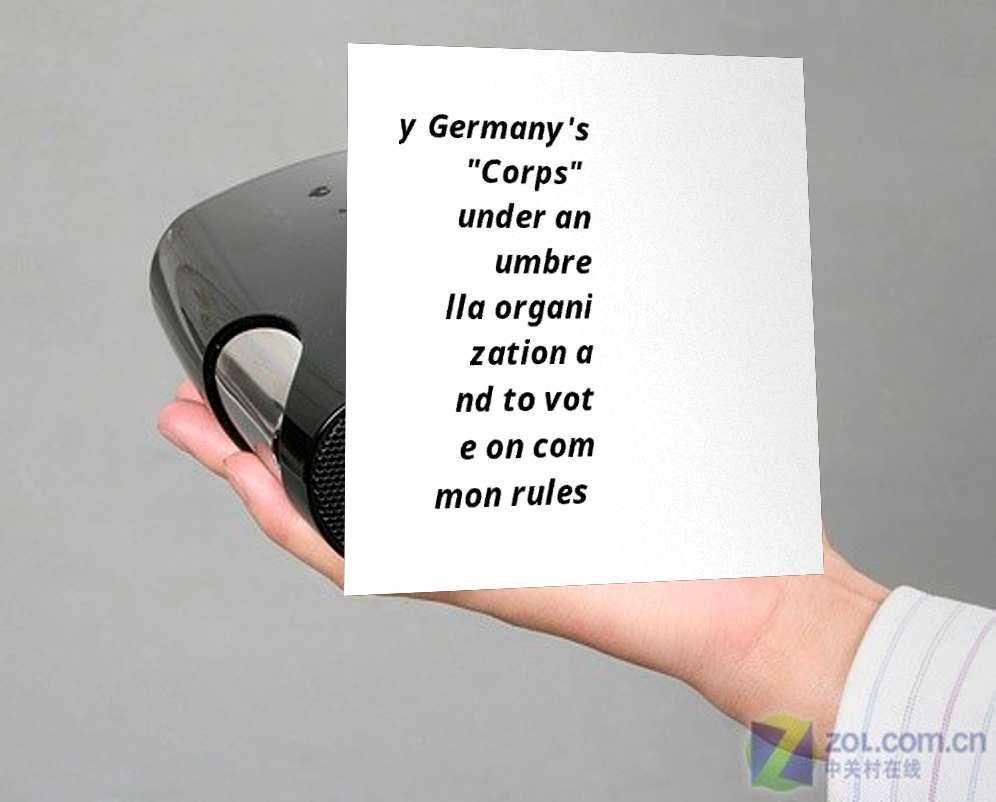I need the written content from this picture converted into text. Can you do that? y Germany's "Corps" under an umbre lla organi zation a nd to vot e on com mon rules 